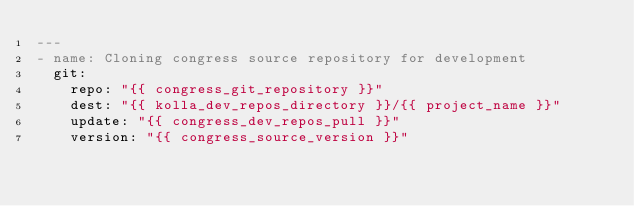<code> <loc_0><loc_0><loc_500><loc_500><_YAML_>---
- name: Cloning congress source repository for development
  git:
    repo: "{{ congress_git_repository }}"
    dest: "{{ kolla_dev_repos_directory }}/{{ project_name }}"
    update: "{{ congress_dev_repos_pull }}"
    version: "{{ congress_source_version }}"
</code> 